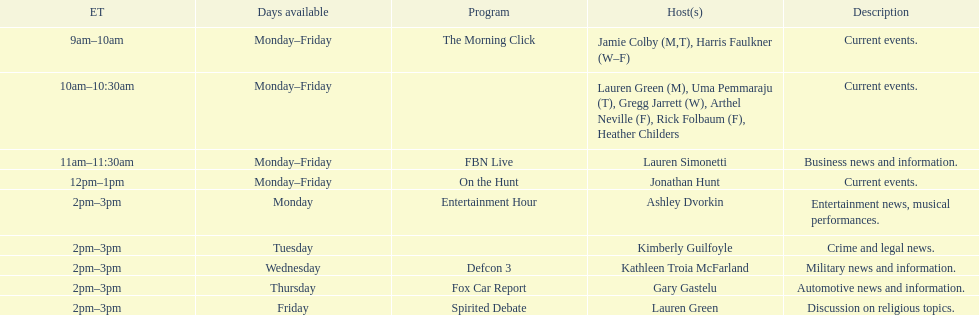How long does on the hunt run? 1 hour. 